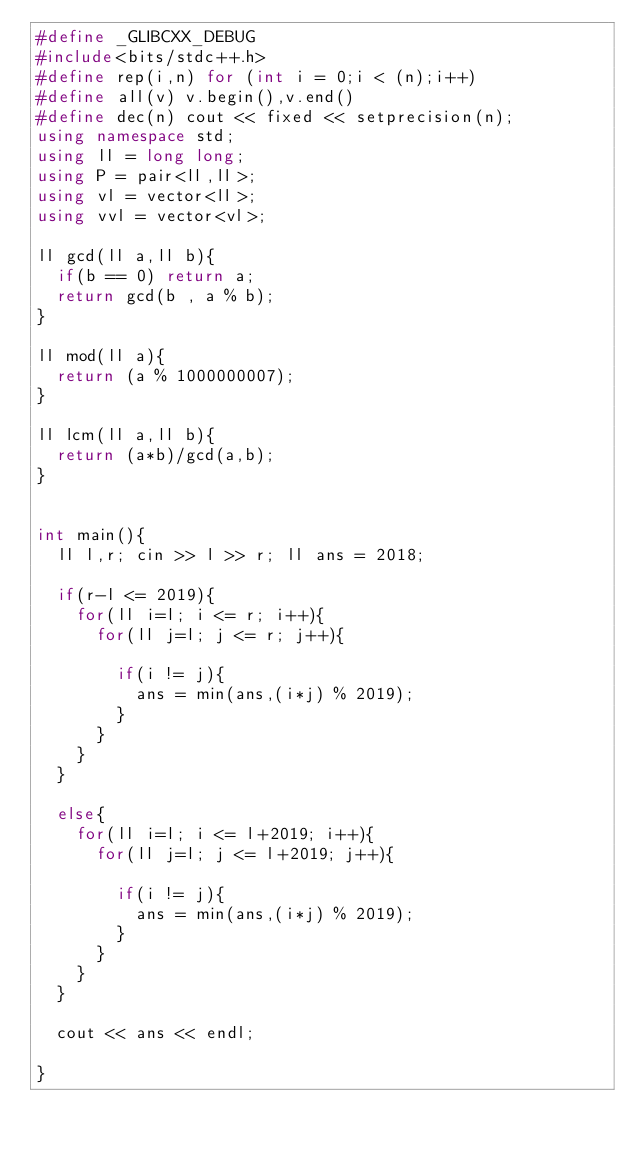Convert code to text. <code><loc_0><loc_0><loc_500><loc_500><_C++_>#define _GLIBCXX_DEBUG
#include<bits/stdc++.h>
#define rep(i,n) for (int i = 0;i < (n);i++)
#define all(v) v.begin(),v.end()
#define dec(n) cout << fixed << setprecision(n);
using namespace std;
using ll = long long;
using P = pair<ll,ll>;
using vl = vector<ll>;
using vvl = vector<vl>;

ll gcd(ll a,ll b){
  if(b == 0) return a;
  return gcd(b , a % b);
}

ll mod(ll a){
  return (a % 1000000007);
}

ll lcm(ll a,ll b){
  return (a*b)/gcd(a,b);
}


int main(){
  ll l,r; cin >> l >> r; ll ans = 2018;
  
  if(r-l <= 2019){
    for(ll i=l; i <= r; i++){
      for(ll j=l; j <= r; j++){
       
        if(i != j){
          ans = min(ans,(i*j) % 2019);
        }
      }
    }
  }
  
  else{
    for(ll i=l; i <= l+2019; i++){
      for(ll j=l; j <= l+2019; j++){
        
        if(i != j){
          ans = min(ans,(i*j) % 2019);
        }
      }
    }
  }
  
  cout << ans << endl;
  
}
  
  </code> 